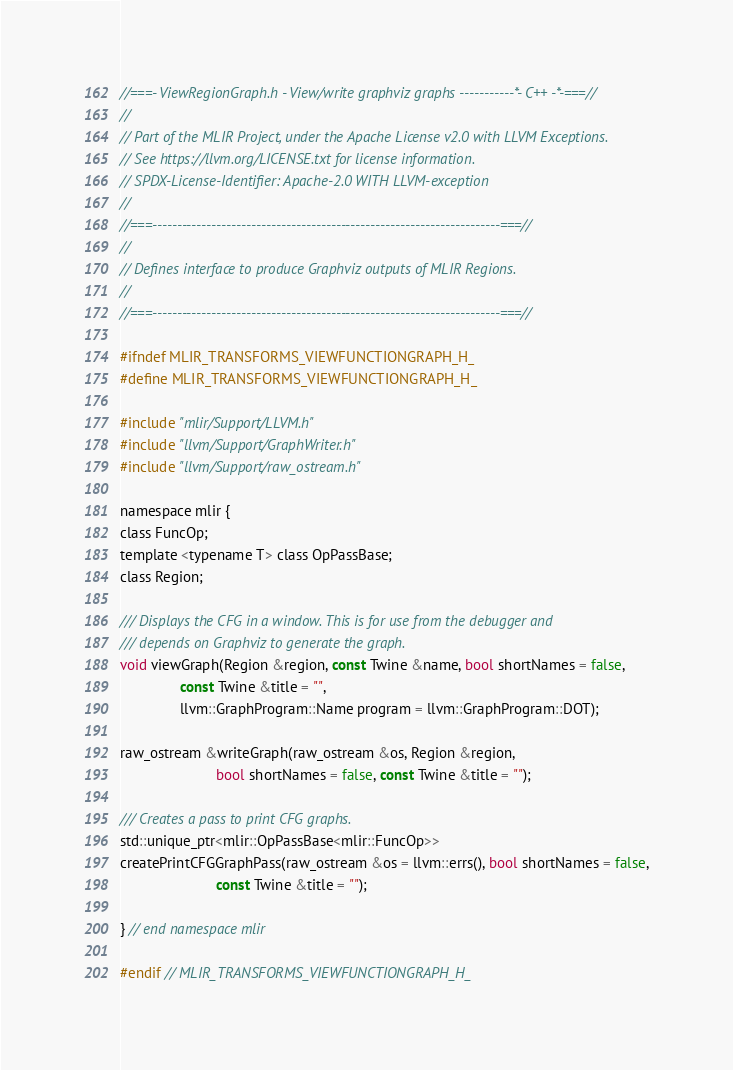<code> <loc_0><loc_0><loc_500><loc_500><_C_>//===- ViewRegionGraph.h - View/write graphviz graphs -----------*- C++ -*-===//
//
// Part of the MLIR Project, under the Apache License v2.0 with LLVM Exceptions.
// See https://llvm.org/LICENSE.txt for license information.
// SPDX-License-Identifier: Apache-2.0 WITH LLVM-exception
//
//===----------------------------------------------------------------------===//
//
// Defines interface to produce Graphviz outputs of MLIR Regions.
//
//===----------------------------------------------------------------------===//

#ifndef MLIR_TRANSFORMS_VIEWFUNCTIONGRAPH_H_
#define MLIR_TRANSFORMS_VIEWFUNCTIONGRAPH_H_

#include "mlir/Support/LLVM.h"
#include "llvm/Support/GraphWriter.h"
#include "llvm/Support/raw_ostream.h"

namespace mlir {
class FuncOp;
template <typename T> class OpPassBase;
class Region;

/// Displays the CFG in a window. This is for use from the debugger and
/// depends on Graphviz to generate the graph.
void viewGraph(Region &region, const Twine &name, bool shortNames = false,
               const Twine &title = "",
               llvm::GraphProgram::Name program = llvm::GraphProgram::DOT);

raw_ostream &writeGraph(raw_ostream &os, Region &region,
                        bool shortNames = false, const Twine &title = "");

/// Creates a pass to print CFG graphs.
std::unique_ptr<mlir::OpPassBase<mlir::FuncOp>>
createPrintCFGGraphPass(raw_ostream &os = llvm::errs(), bool shortNames = false,
                        const Twine &title = "");

} // end namespace mlir

#endif // MLIR_TRANSFORMS_VIEWFUNCTIONGRAPH_H_
</code> 